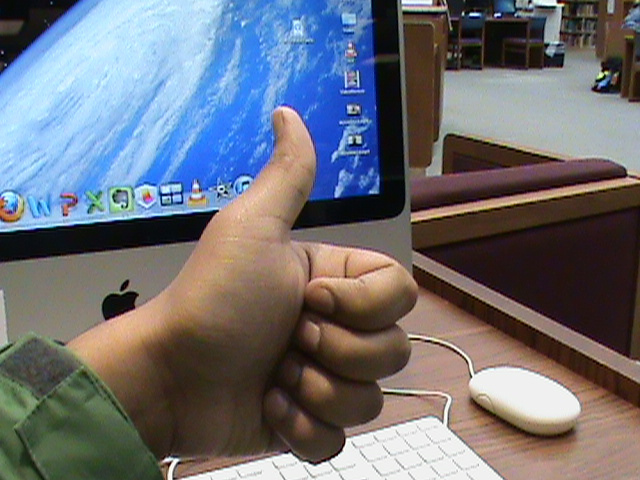Identify the text displayed in this image. W X 